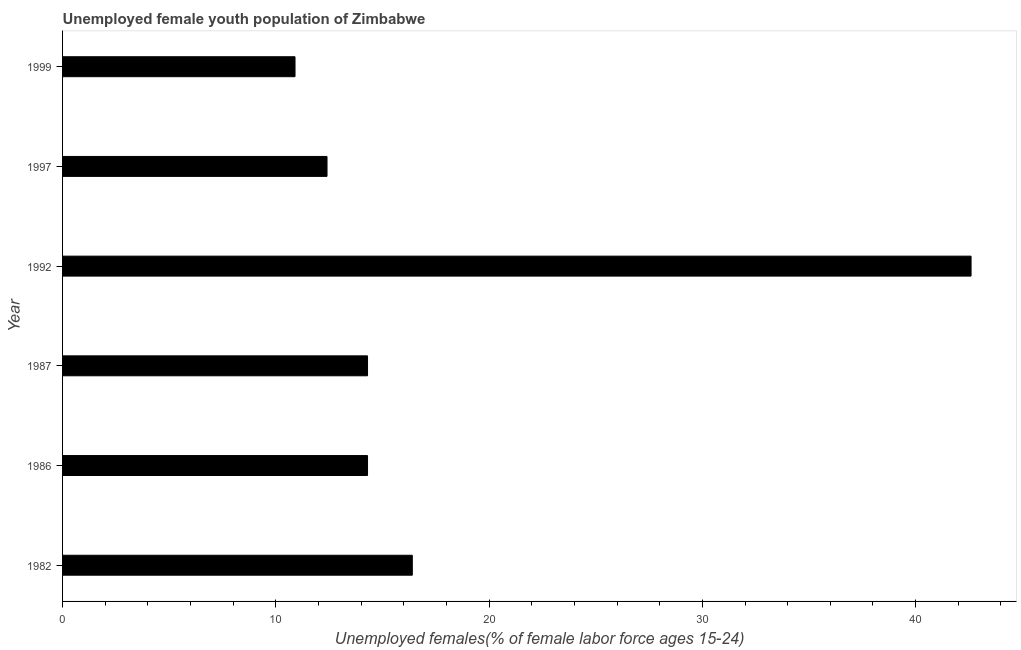What is the title of the graph?
Provide a succinct answer. Unemployed female youth population of Zimbabwe. What is the label or title of the X-axis?
Give a very brief answer. Unemployed females(% of female labor force ages 15-24). What is the label or title of the Y-axis?
Your answer should be compact. Year. What is the unemployed female youth in 1997?
Provide a succinct answer. 12.4. Across all years, what is the maximum unemployed female youth?
Keep it short and to the point. 42.6. Across all years, what is the minimum unemployed female youth?
Provide a short and direct response. 10.9. In which year was the unemployed female youth maximum?
Keep it short and to the point. 1992. What is the sum of the unemployed female youth?
Your answer should be very brief. 110.9. What is the difference between the unemployed female youth in 1992 and 1997?
Your answer should be compact. 30.2. What is the average unemployed female youth per year?
Your answer should be compact. 18.48. What is the median unemployed female youth?
Your response must be concise. 14.3. Is the unemployed female youth in 1986 less than that in 1992?
Offer a very short reply. Yes. Is the difference between the unemployed female youth in 1986 and 1999 greater than the difference between any two years?
Provide a succinct answer. No. What is the difference between the highest and the second highest unemployed female youth?
Ensure brevity in your answer.  26.2. What is the difference between the highest and the lowest unemployed female youth?
Offer a very short reply. 31.7. In how many years, is the unemployed female youth greater than the average unemployed female youth taken over all years?
Give a very brief answer. 1. How many years are there in the graph?
Provide a succinct answer. 6. Are the values on the major ticks of X-axis written in scientific E-notation?
Keep it short and to the point. No. What is the Unemployed females(% of female labor force ages 15-24) in 1982?
Provide a short and direct response. 16.4. What is the Unemployed females(% of female labor force ages 15-24) of 1986?
Ensure brevity in your answer.  14.3. What is the Unemployed females(% of female labor force ages 15-24) in 1987?
Ensure brevity in your answer.  14.3. What is the Unemployed females(% of female labor force ages 15-24) in 1992?
Offer a very short reply. 42.6. What is the Unemployed females(% of female labor force ages 15-24) of 1997?
Offer a terse response. 12.4. What is the Unemployed females(% of female labor force ages 15-24) of 1999?
Give a very brief answer. 10.9. What is the difference between the Unemployed females(% of female labor force ages 15-24) in 1982 and 1992?
Give a very brief answer. -26.2. What is the difference between the Unemployed females(% of female labor force ages 15-24) in 1982 and 1997?
Make the answer very short. 4. What is the difference between the Unemployed females(% of female labor force ages 15-24) in 1986 and 1992?
Your response must be concise. -28.3. What is the difference between the Unemployed females(% of female labor force ages 15-24) in 1986 and 1997?
Provide a succinct answer. 1.9. What is the difference between the Unemployed females(% of female labor force ages 15-24) in 1986 and 1999?
Your response must be concise. 3.4. What is the difference between the Unemployed females(% of female labor force ages 15-24) in 1987 and 1992?
Offer a very short reply. -28.3. What is the difference between the Unemployed females(% of female labor force ages 15-24) in 1987 and 1997?
Make the answer very short. 1.9. What is the difference between the Unemployed females(% of female labor force ages 15-24) in 1992 and 1997?
Provide a short and direct response. 30.2. What is the difference between the Unemployed females(% of female labor force ages 15-24) in 1992 and 1999?
Your answer should be very brief. 31.7. What is the difference between the Unemployed females(% of female labor force ages 15-24) in 1997 and 1999?
Offer a terse response. 1.5. What is the ratio of the Unemployed females(% of female labor force ages 15-24) in 1982 to that in 1986?
Offer a very short reply. 1.15. What is the ratio of the Unemployed females(% of female labor force ages 15-24) in 1982 to that in 1987?
Your response must be concise. 1.15. What is the ratio of the Unemployed females(% of female labor force ages 15-24) in 1982 to that in 1992?
Your response must be concise. 0.39. What is the ratio of the Unemployed females(% of female labor force ages 15-24) in 1982 to that in 1997?
Provide a succinct answer. 1.32. What is the ratio of the Unemployed females(% of female labor force ages 15-24) in 1982 to that in 1999?
Ensure brevity in your answer.  1.5. What is the ratio of the Unemployed females(% of female labor force ages 15-24) in 1986 to that in 1992?
Offer a terse response. 0.34. What is the ratio of the Unemployed females(% of female labor force ages 15-24) in 1986 to that in 1997?
Your answer should be very brief. 1.15. What is the ratio of the Unemployed females(% of female labor force ages 15-24) in 1986 to that in 1999?
Provide a short and direct response. 1.31. What is the ratio of the Unemployed females(% of female labor force ages 15-24) in 1987 to that in 1992?
Your answer should be compact. 0.34. What is the ratio of the Unemployed females(% of female labor force ages 15-24) in 1987 to that in 1997?
Make the answer very short. 1.15. What is the ratio of the Unemployed females(% of female labor force ages 15-24) in 1987 to that in 1999?
Your response must be concise. 1.31. What is the ratio of the Unemployed females(% of female labor force ages 15-24) in 1992 to that in 1997?
Make the answer very short. 3.44. What is the ratio of the Unemployed females(% of female labor force ages 15-24) in 1992 to that in 1999?
Offer a very short reply. 3.91. What is the ratio of the Unemployed females(% of female labor force ages 15-24) in 1997 to that in 1999?
Give a very brief answer. 1.14. 